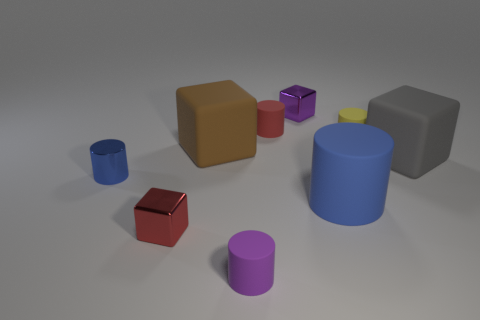Subtract all big cylinders. How many cylinders are left? 4 Subtract 1 cylinders. How many cylinders are left? 4 Subtract all red cylinders. How many cylinders are left? 4 Subtract all brown cylinders. Subtract all yellow cubes. How many cylinders are left? 5 Subtract all cylinders. How many objects are left? 4 Subtract 0 green cylinders. How many objects are left? 9 Subtract all tiny shiny things. Subtract all brown rubber blocks. How many objects are left? 5 Add 6 purple rubber cylinders. How many purple rubber cylinders are left? 7 Add 8 matte blocks. How many matte blocks exist? 10 